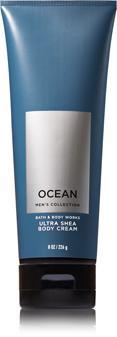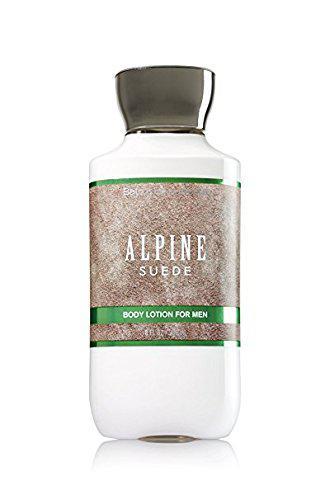The first image is the image on the left, the second image is the image on the right. Examine the images to the left and right. Is the description "An image features one product that stands on its black cap." accurate? Answer yes or no. Yes. The first image is the image on the left, the second image is the image on the right. For the images displayed, is the sentence "There are two bottles, both with black caps and white content." factually correct? Answer yes or no. No. 